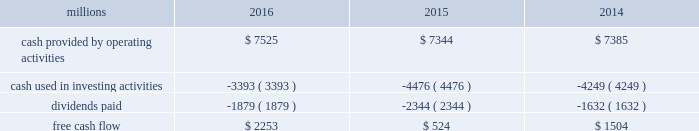To , rather than as a substitute for , cash provided by operating activities .
The table reconciles cash provided by operating activities ( gaap measure ) to free cash flow ( non-gaap measure ) : .
2017 outlook f0b7 safety 2013 operating a safe railroad benefits all our constituents : our employees , customers , shareholders and the communities we serve .
We will continue using a multi-faceted approach to safety , utilizing technology , risk assessment , training and employee engagement , quality control , and targeted capital investments .
We will continue using and expanding the deployment of total safety culture and courage to care throughout our operations , which allows us to identify and implement best practices for employee and operational safety .
We will continue our efforts to increase detection of rail defects ; improve or close crossings ; and educate the public and law enforcement agencies about crossing safety through a combination of our own programs ( including risk assessment strategies ) , industry programs and local community activities across our network .
F0b7 network operations 2013 in 2017 , we will continue to align resources with customer demand , maintain an efficient network , and ensure surge capability with our assets .
F0b7 fuel prices 2013 fuel price projections for crude oil and natural gas continue to fluctuate in the current environment .
We again could see volatile fuel prices during the year , as they are sensitive to global and u.s .
Domestic demand , refining capacity , geopolitical events , weather conditions and other factors .
As prices fluctuate , there will be a timing impact on earnings , as our fuel surcharge programs trail increases or decreases in fuel price by approximately two months .
Continuing lower fuel prices could have a positive impact on the economy by increasing consumer discretionary spending that potentially could increase demand for various consumer products that we transport .
Alternatively , lower fuel prices could likely have a negative impact on other commodities such as coal and domestic drilling-related shipments .
F0b7 capital plan 2013 in 2017 , we expect our capital plan to be approximately $ 3.1 billion , including expenditures for ptc , approximately 60 locomotives scheduled to be delivered , and intermodal containers and chassis , and freight cars .
The capital plan may be revised if business conditions warrant or if new laws or regulations affect our ability to generate sufficient returns on these investments .
( see further discussion in this item 7 under liquidity and capital resources 2013 capital plan. ) f0b7 financial expectations 2013 economic conditions in many of our market sectors continue to drive uncertainty with respect to our volume levels .
We expect volume to grow in the low single digit range in 2017 compared to 2016 , but it will depend on the overall economy and market conditions .
One of the more significant uncertainties is the outlook for energy markets , which will bring both challenges and opportunities .
In the current environment , we expect continued margin improvement driven by continued pricing opportunities , ongoing productivity initiatives , and the ability to leverage our resources and strengthen our franchise .
Over the longer term , we expect the overall u.s .
Economy to continue to improve at a modest pace , with some markets outperforming others. .
What was the percentage of dividends paid to cash provided by operating activities in 2015? 
Computations: (2344 / 7344)
Answer: 0.31917. 